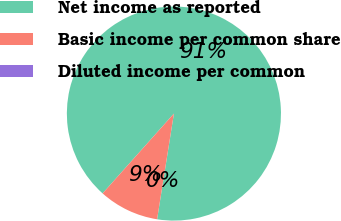Convert chart. <chart><loc_0><loc_0><loc_500><loc_500><pie_chart><fcel>Net income as reported<fcel>Basic income per common share<fcel>Diluted income per common<nl><fcel>90.91%<fcel>9.09%<fcel>0.0%<nl></chart> 